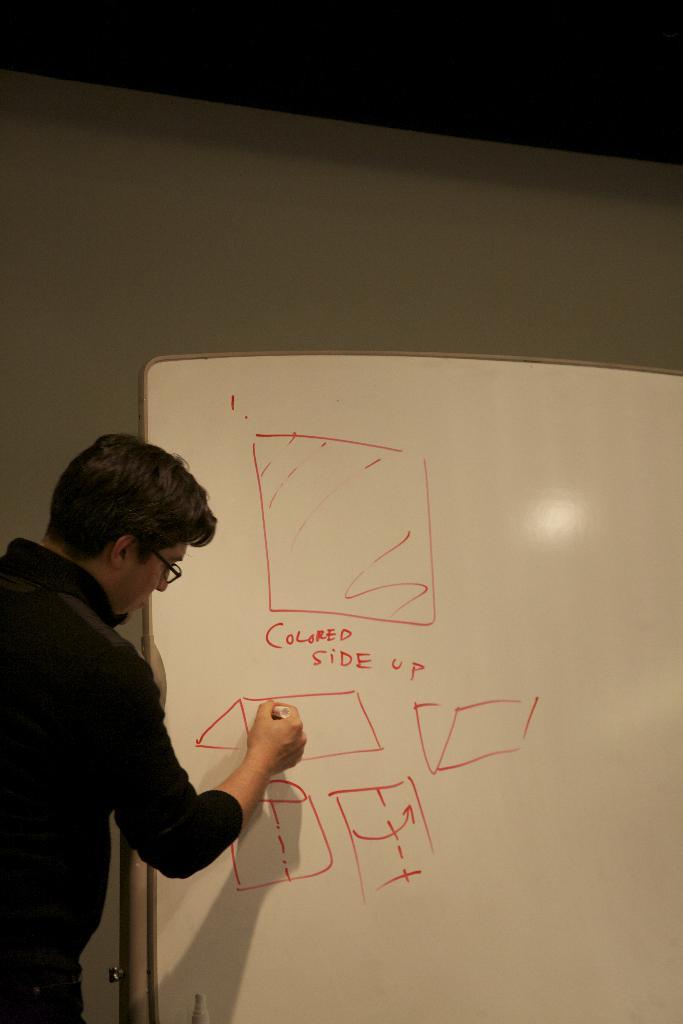What does the board say?
Give a very brief answer. Colored side up. What side is up?
Your response must be concise. Colored. 